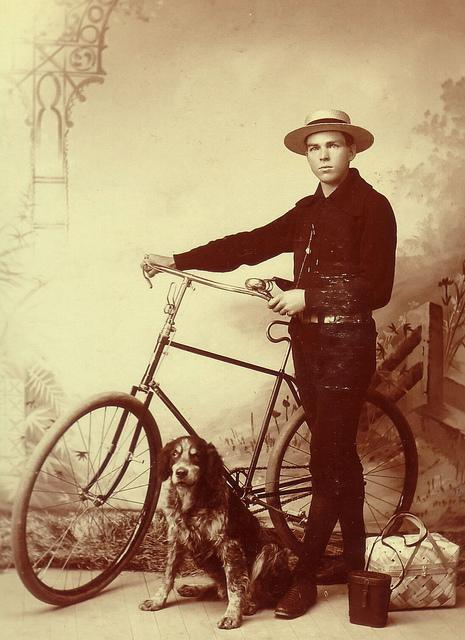What purpose is the bike serving right now? Please explain your reasoning. prop. The bike owner is holding it to one side to create a pictorial detail. 